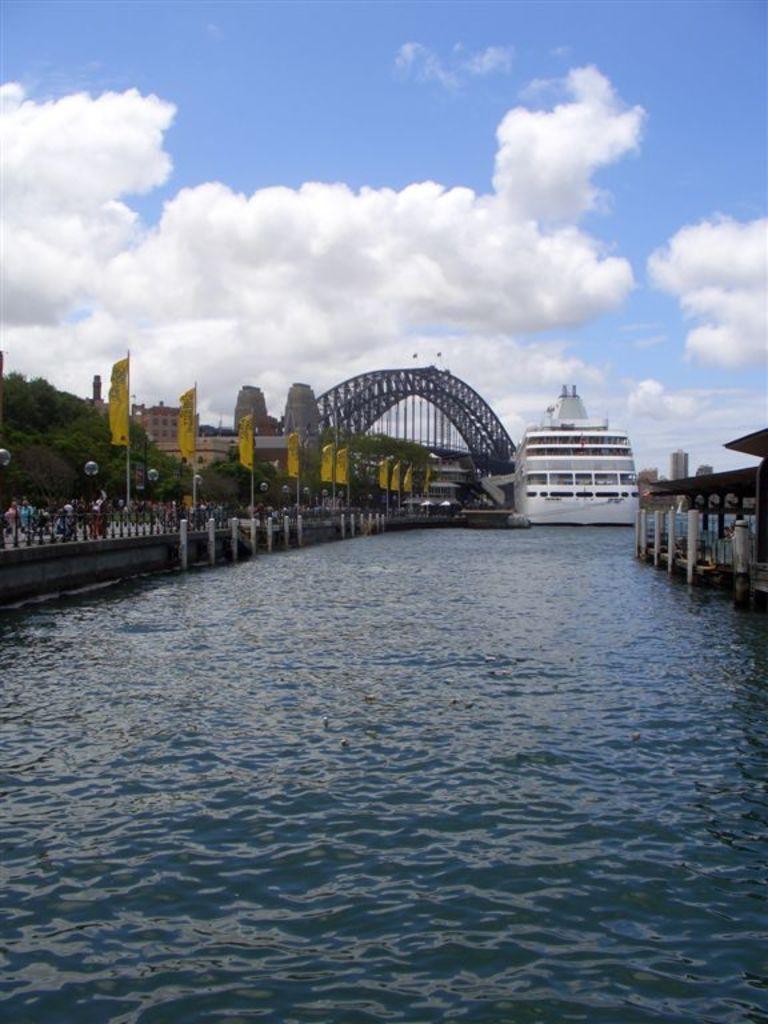How would you summarize this image in a sentence or two? In this image at the center there is water and we can see a ship in the water. On both right and left side of the image there are bridges and people are walking on the bridge. On the left side of the image there are yellow flags. In the background there are trees, buildings and sky. 